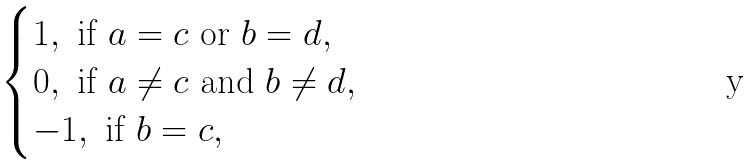Convert formula to latex. <formula><loc_0><loc_0><loc_500><loc_500>\begin{cases} 1 , \text { if } a = c \text { or } b = d , \\ 0 , \text { if } a \neq c \text { and } b \neq d , \\ - 1 , \text { if } b = c , \end{cases}</formula> 